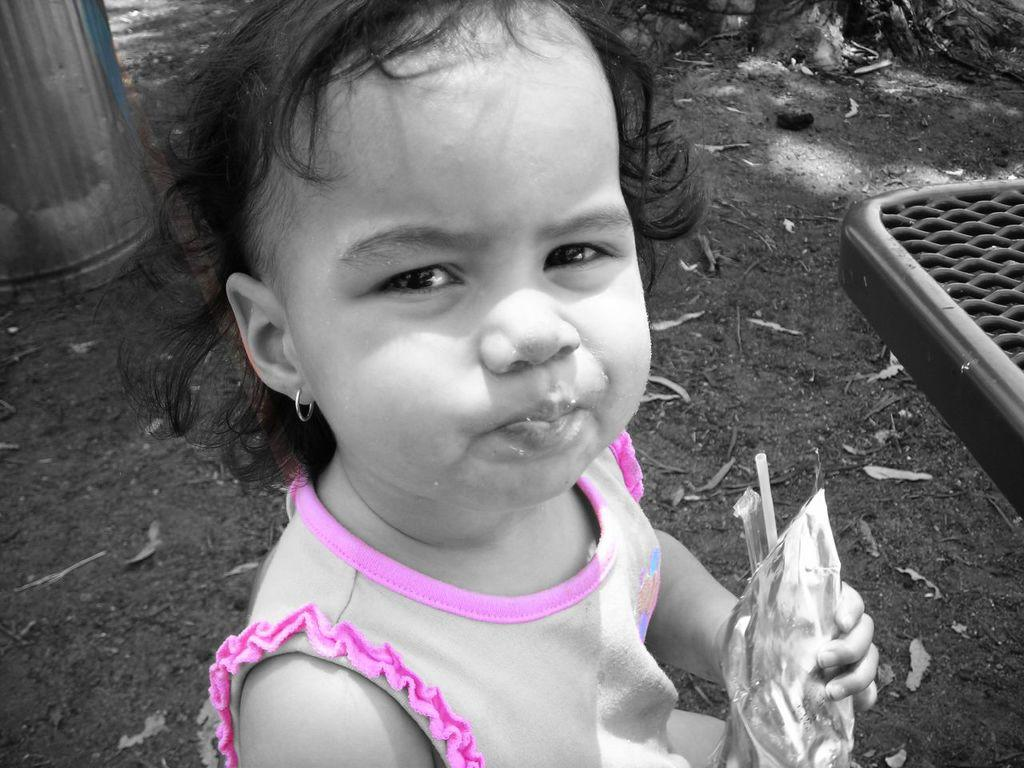Who or what is present in the image? There is a person in the image. What is the person wearing? The person is wearing a pink and white color dress. What is the person holding in the image? The person is holding an object. What can be seen in the background of the image? There are trees in the background of the image. How many snails can be seen climbing the trees in the background of the image? There are no snails visible in the image, as the focus is on the person and their clothing. 